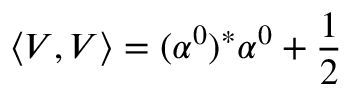<formula> <loc_0><loc_0><loc_500><loc_500>\left \langle V , V \right \rangle = ( \alpha ^ { 0 } ) ^ { * } \alpha ^ { 0 } + \frac { 1 } { 2 }</formula> 